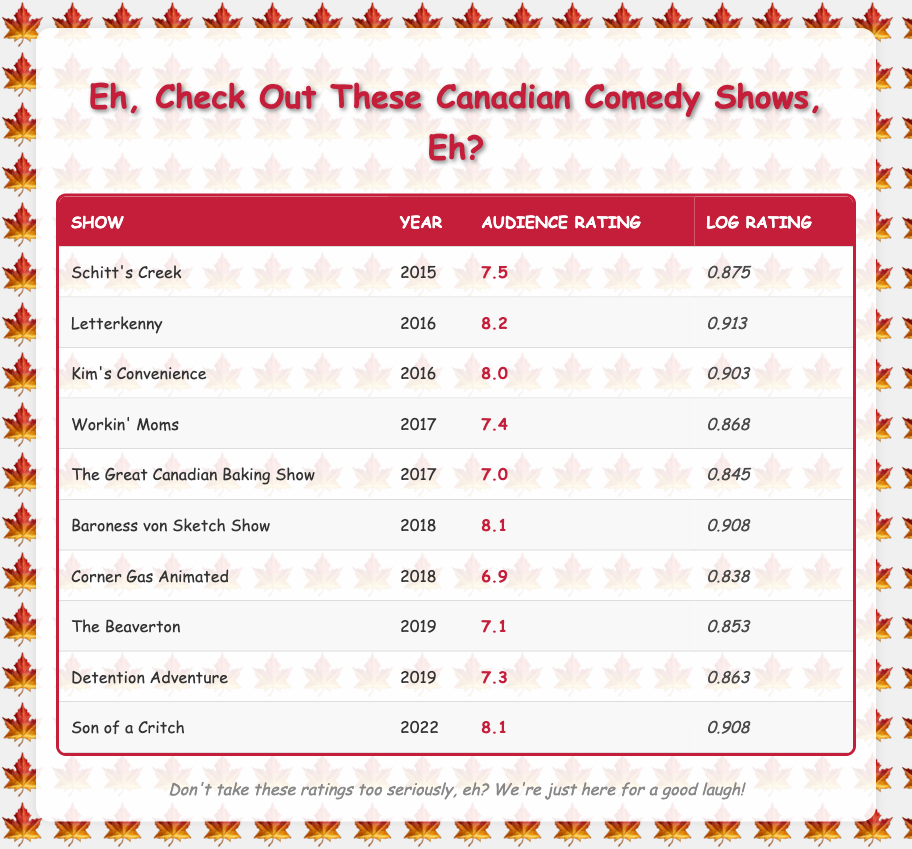What's the audience rating of Schitt's Creek? The table directly lists the audience rating for Schitt's Creek in the corresponding row. It shows the rating as 7.5.
Answer: 7.5 Which show had the highest audience rating? To find the highest audience rating, we need to compare the audience ratings across all shows. In the table, Letterkenny has the highest rating of 8.2, which is greater than all other listed shows.
Answer: 8.2 What is the average audience rating of shows from 2017? The shows from 2017 are Workin' Moms (7.4) and The Great Canadian Baking Show (7.0). To find the average: (7.4 + 7.0) / 2 = 7.2.
Answer: 7.2 Did Corner Gas Animated have an audience rating above 7? By looking at the table, Corner Gas Animated has an audience rating of 6.9, which is below 7.
Answer: No How many shows have an audience rating of 8.0 or higher? From the table, the shows with ratings of 8.0 or higher are Letterkenny (8.2), Kim's Convenience (8.0), Baroness von Sketch Show (8.1), and Son of a Critch (8.1). This counts to four shows in total.
Answer: 4 What is the difference between the highest and lowest audience ratings in the table? The highest rating is 8.2 from Letterkenny and the lowest rating is 6.9 from Corner Gas Animated. Calculating the difference: 8.2 - 6.9 = 1.3.
Answer: 1.3 Was there any show in 2019 with an audience rating less than 7? The shows for 2019 are The Beaverton (7.1) and Detention Adventure (7.3), both of which have ratings above 7. Therefore, no show has a rating below 7.
Answer: No Which year had the highest-rated Canadian comedy show? The highest audience rating overall is 8.2 for Letterkenny in 2016. Thus, 2016 had the highest-rated show.
Answer: 2016 